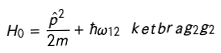<formula> <loc_0><loc_0><loc_500><loc_500>H _ { 0 } = \frac { \hat { p } ^ { 2 } } { 2 m } + \hbar { \omega } _ { 1 2 } \ k e t b r a { g _ { 2 } } { g _ { 2 } }</formula> 